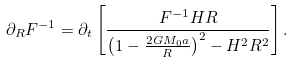<formula> <loc_0><loc_0><loc_500><loc_500>\partial _ { R } F ^ { - 1 } = \partial _ { t } \left [ \frac { F ^ { - 1 } H R } { \left ( 1 - \frac { 2 G M _ { 0 } a } { R } \right ) ^ { 2 } - H ^ { 2 } R ^ { 2 } } \right ] .</formula> 